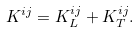<formula> <loc_0><loc_0><loc_500><loc_500>K ^ { i j } = K ^ { i j } _ { L } + K ^ { i j } _ { T } .</formula> 